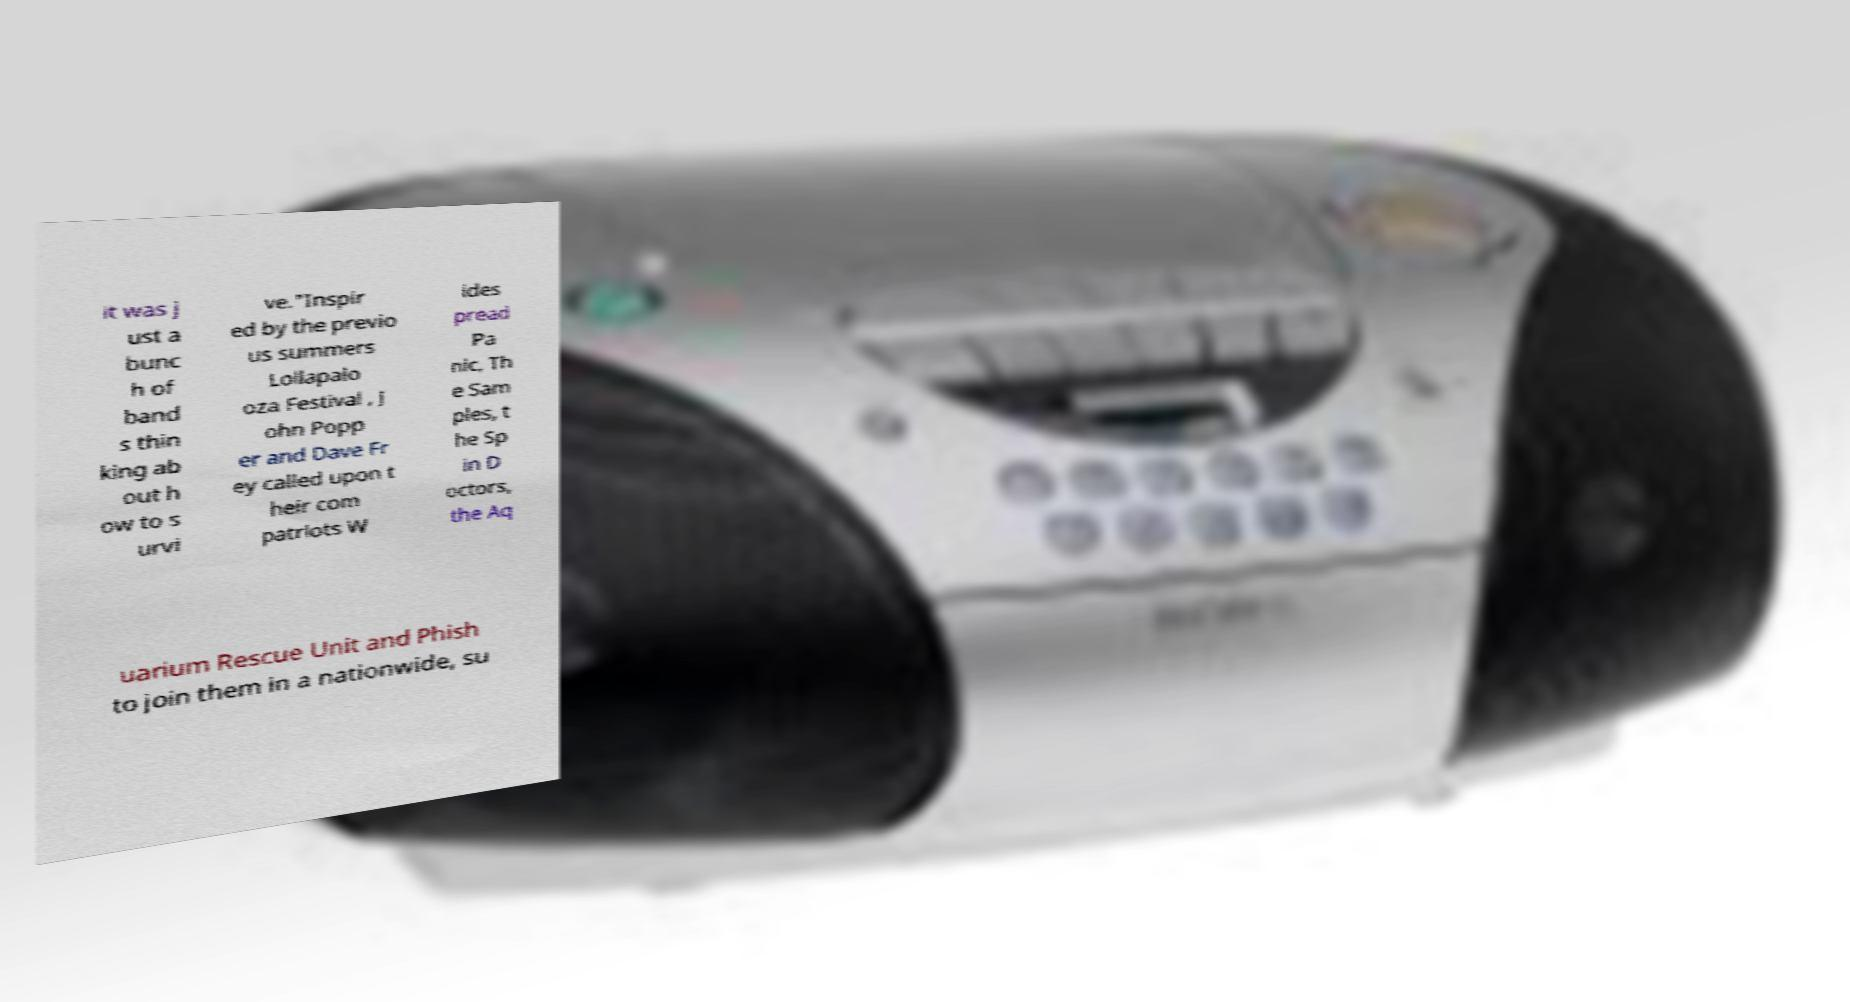Can you accurately transcribe the text from the provided image for me? it was j ust a bunc h of band s thin king ab out h ow to s urvi ve."Inspir ed by the previo us summers Lollapalo oza Festival , J ohn Popp er and Dave Fr ey called upon t heir com patriots W ides pread Pa nic, Th e Sam ples, t he Sp in D octors, the Aq uarium Rescue Unit and Phish to join them in a nationwide, su 